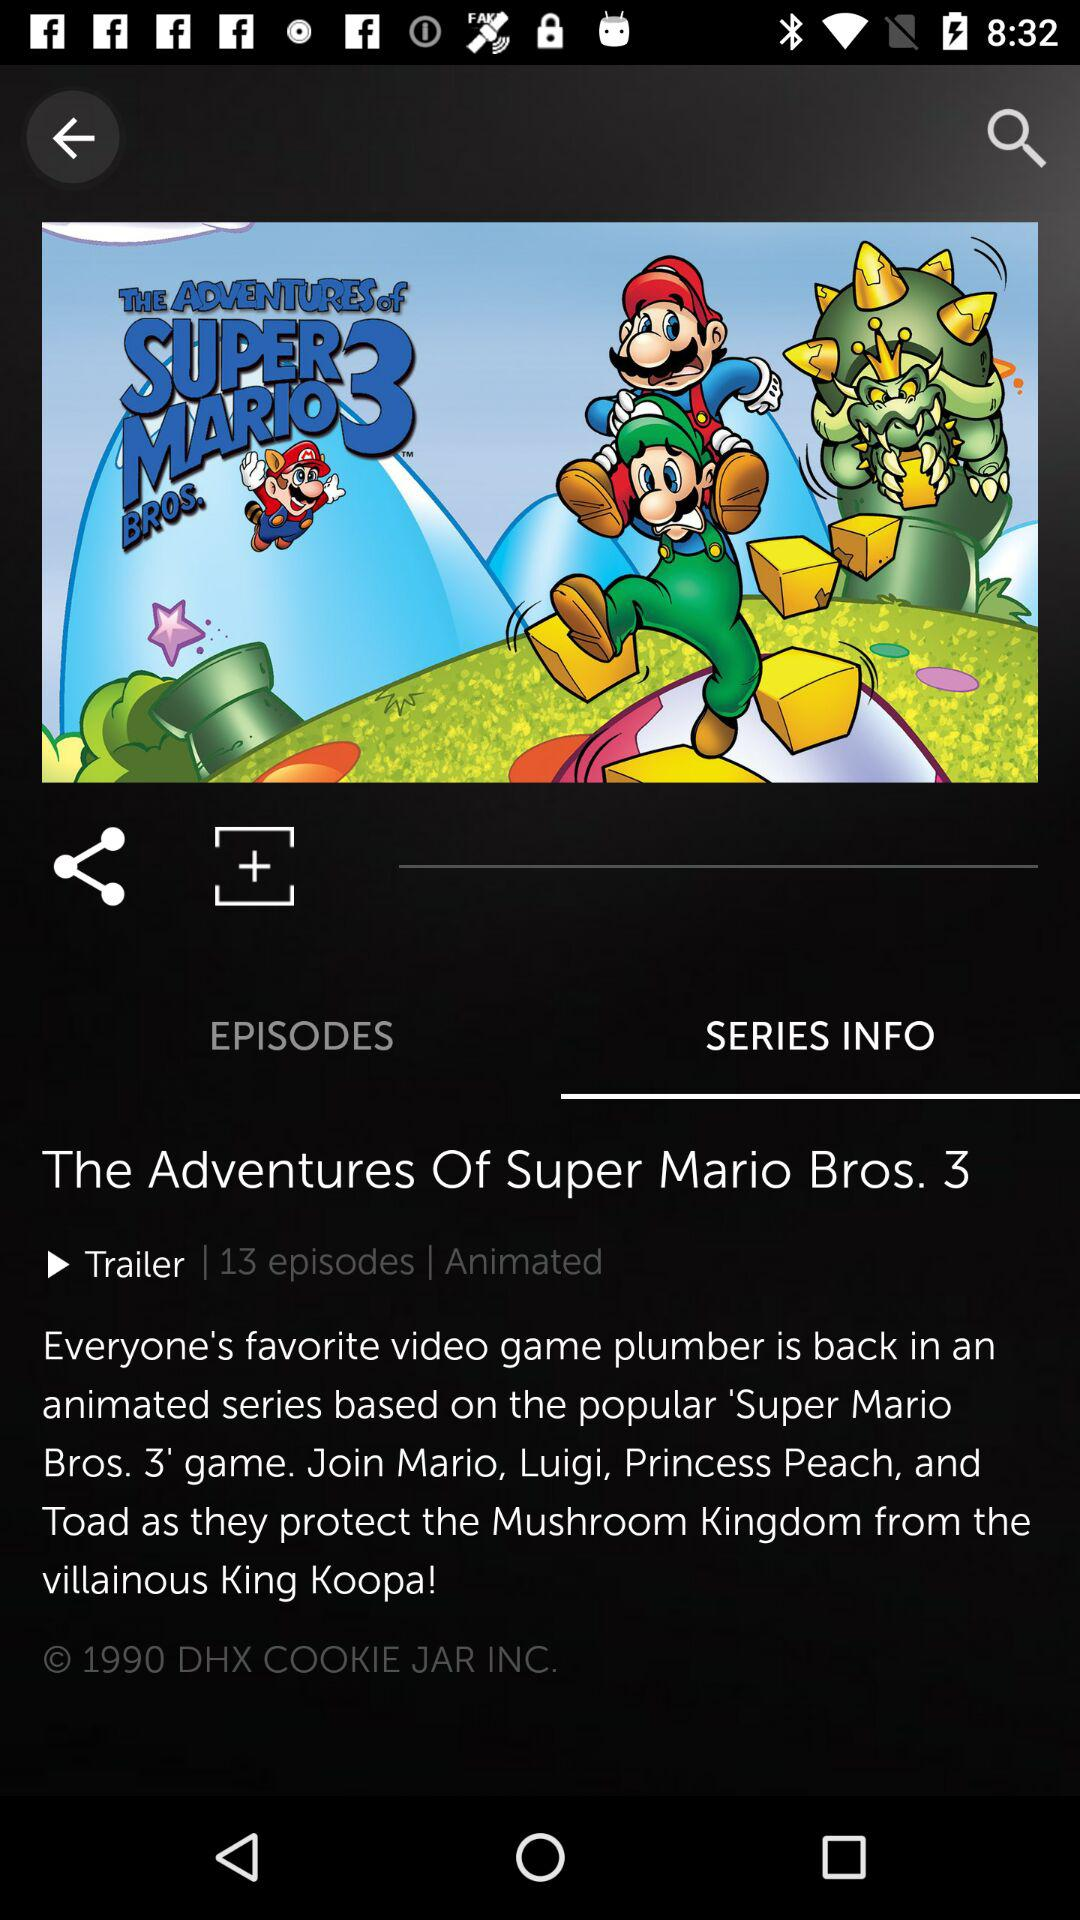How many episodes are there? There are 13 episodes. 